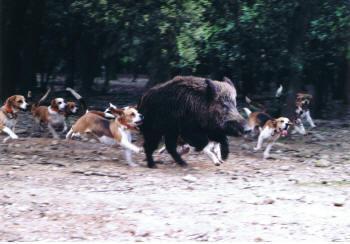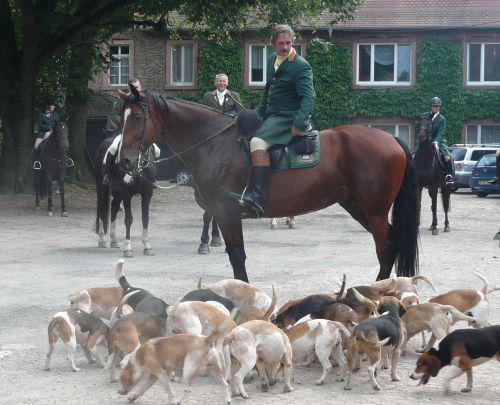The first image is the image on the left, the second image is the image on the right. Evaluate the accuracy of this statement regarding the images: "Some of the dogs are compacted in a group that are all facing to the immediate left.". Is it true? Answer yes or no. No. The first image is the image on the left, the second image is the image on the right. Assess this claim about the two images: "In at least one image the beagles are near adult humans.". Correct or not? Answer yes or no. Yes. 